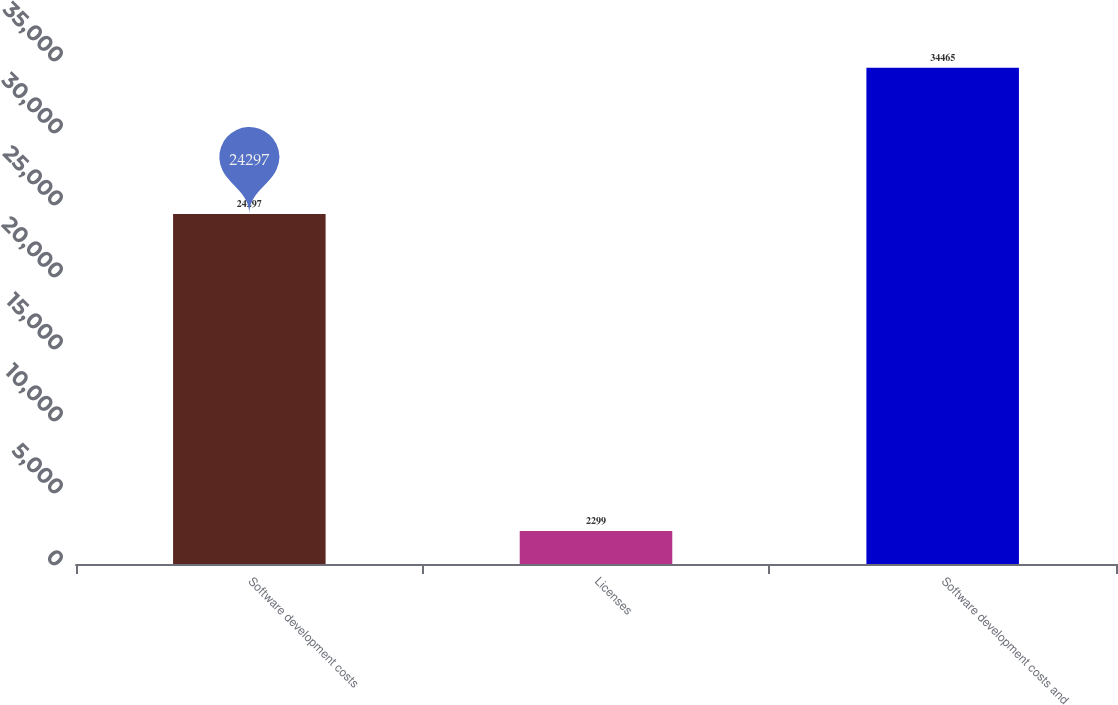<chart> <loc_0><loc_0><loc_500><loc_500><bar_chart><fcel>Software development costs<fcel>Licenses<fcel>Software development costs and<nl><fcel>24297<fcel>2299<fcel>34465<nl></chart> 